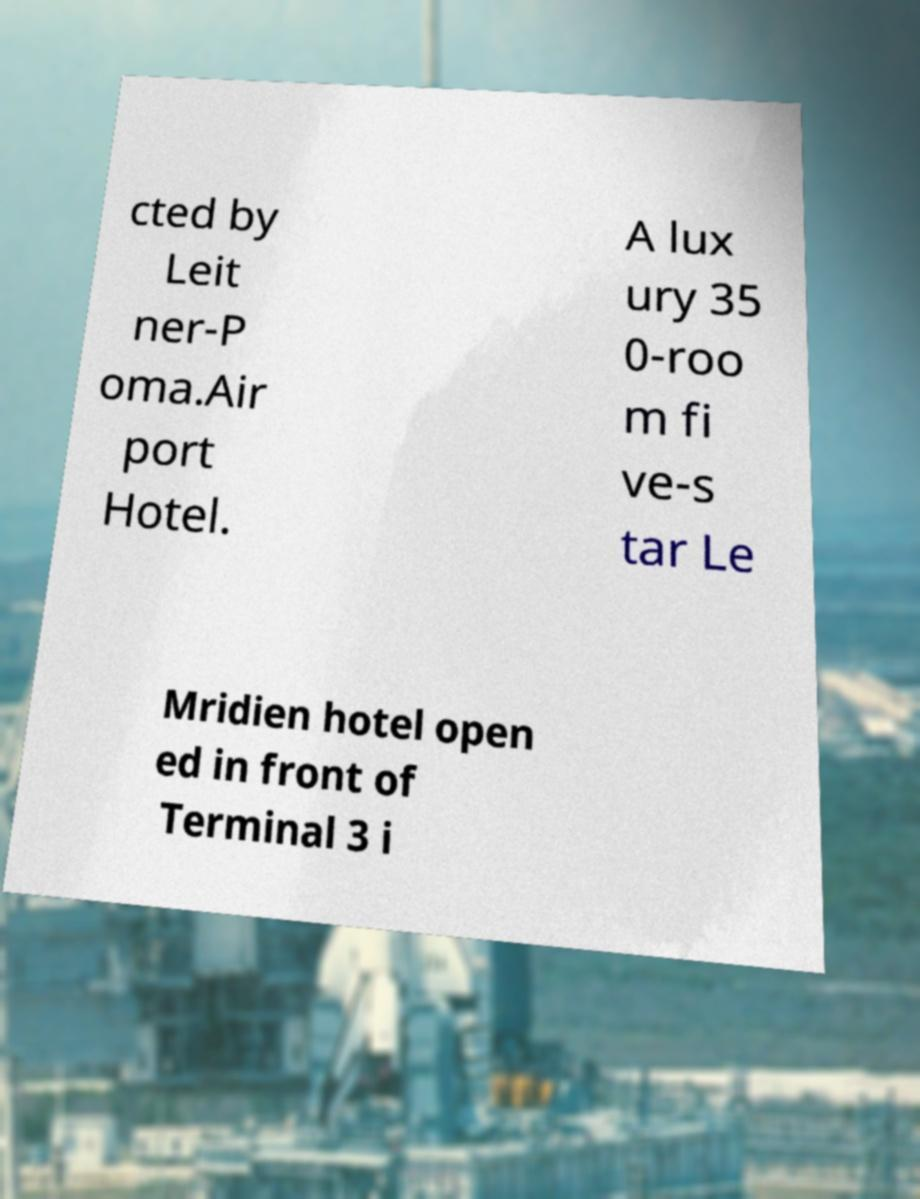Please identify and transcribe the text found in this image. cted by Leit ner-P oma.Air port Hotel. A lux ury 35 0-roo m fi ve-s tar Le Mridien hotel open ed in front of Terminal 3 i 